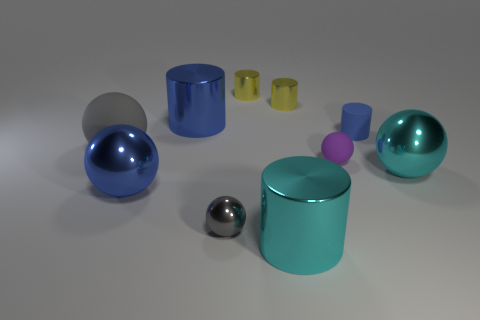Subtract 2 cylinders. How many cylinders are left? 3 Subtract all cyan cylinders. How many cylinders are left? 4 Subtract all large blue metal balls. How many balls are left? 4 Subtract all purple cylinders. Subtract all blue blocks. How many cylinders are left? 5 Subtract 0 red balls. How many objects are left? 10 Subtract all large gray spheres. Subtract all blue shiny cylinders. How many objects are left? 8 Add 3 large cylinders. How many large cylinders are left? 5 Add 6 big metallic things. How many big metallic things exist? 10 